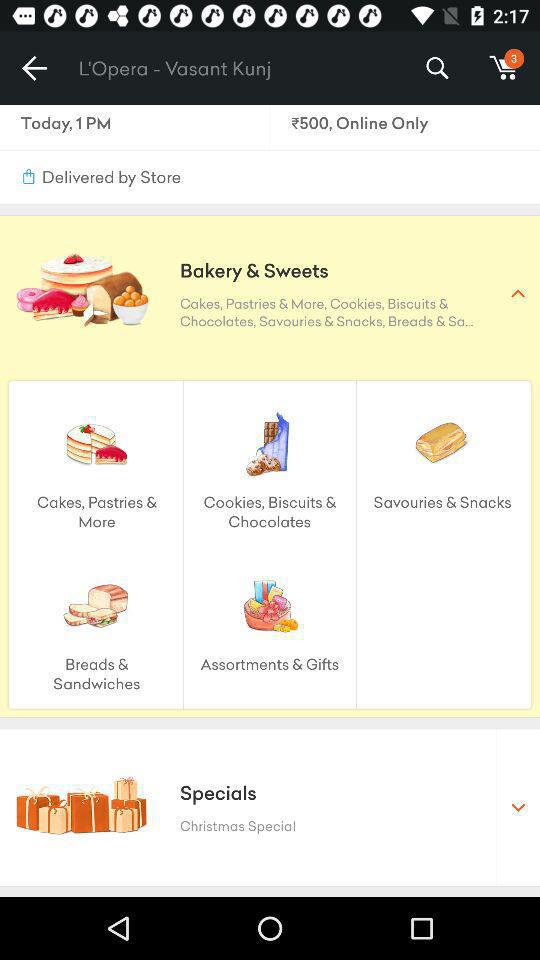What are the different recipes?
When the provided information is insufficient, respond with <no answer>. <no answer> 